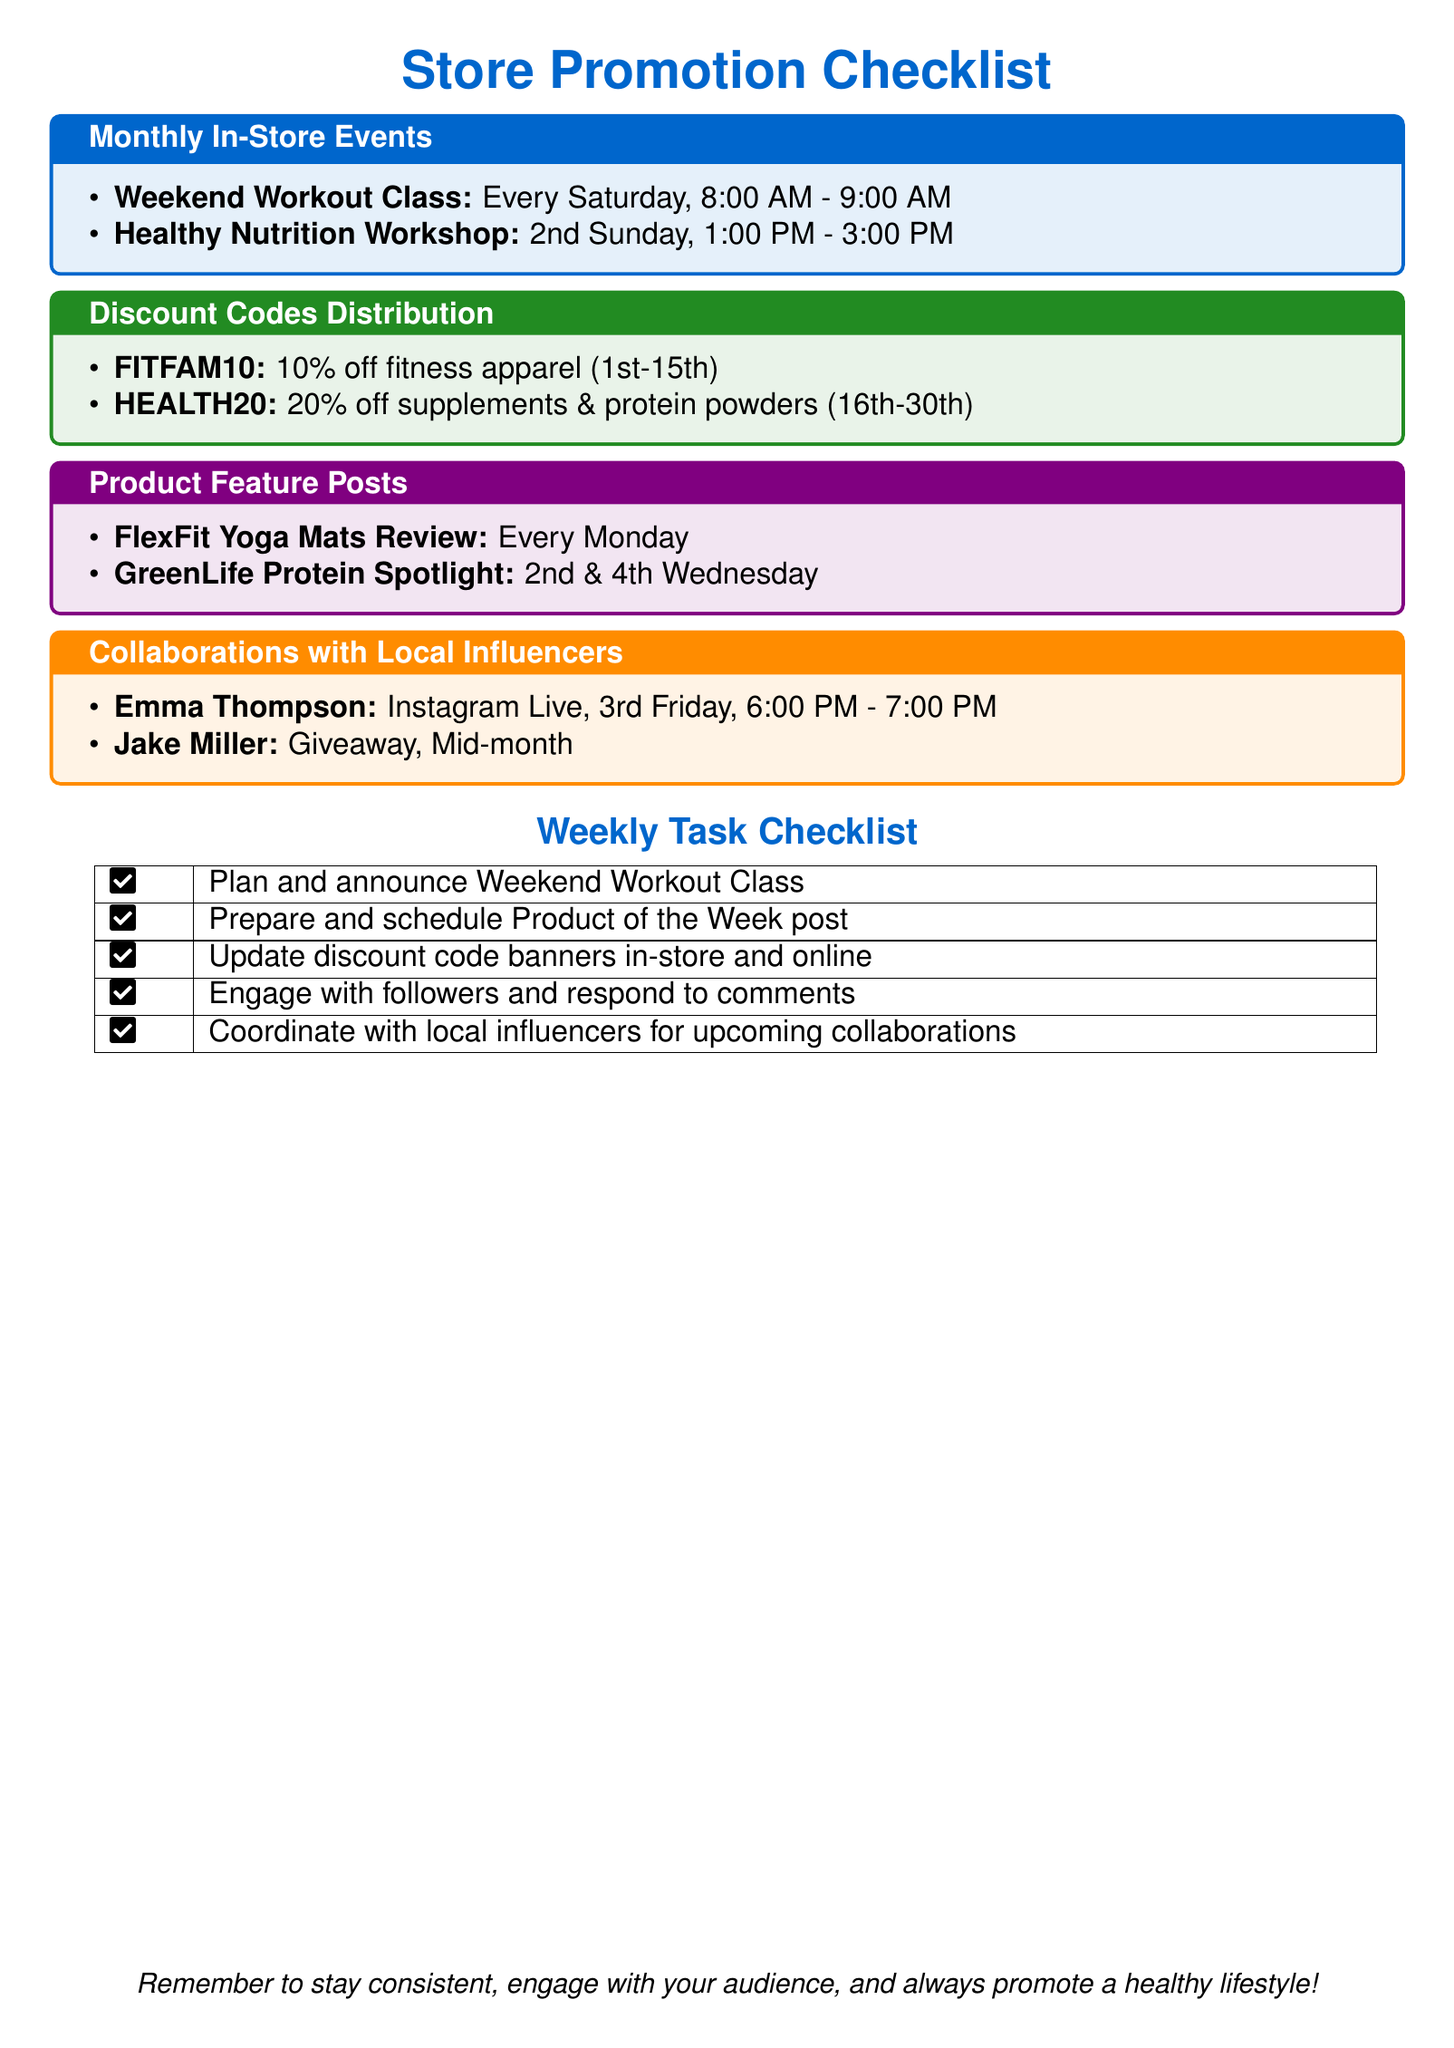What day is the Healthy Nutrition Workshop held? The Healthy Nutrition Workshop is scheduled for the 2nd Sunday of the month at 1:00 PM.
Answer: 2nd Sunday What is the discount percentage for the FITFAM10 code? The FITFAM10 code offers a 10% discount on fitness apparel from the 1st to the 15th of the month.
Answer: 10% When does the Instagram Live with Emma Thompson occur? Emma Thompson's Instagram Live is set for the 3rd Friday of the month from 6:00 PM to 7:00 PM.
Answer: 3rd Friday Which product is featured every Monday? The product that gets reviewed every Monday is the FlexFit Yoga Mats.
Answer: FlexFit Yoga Mats What discount code applies to supplements and protein powders? The discount code for supplements and protein powders is HEALTH20, valid from the 16th to the 30th of the month.
Answer: HEALTH20 What is the frequency of the GreenLife Protein Spotlight posts? The GreenLife Protein Spotlight posts are scheduled for the 2nd and 4th Wednesdays of the month.
Answer: 2nd & 4th Wednesday Which local influencer is involved in a mid-month giveaway? Jake Miller is the local influencer who is participating in a giveaway scheduled for mid-month.
Answer: Jake Miller What time does the Weekend Workout Class start? The Weekend Workout Class starts at 8:00 AM every Saturday.
Answer: 8:00 AM 